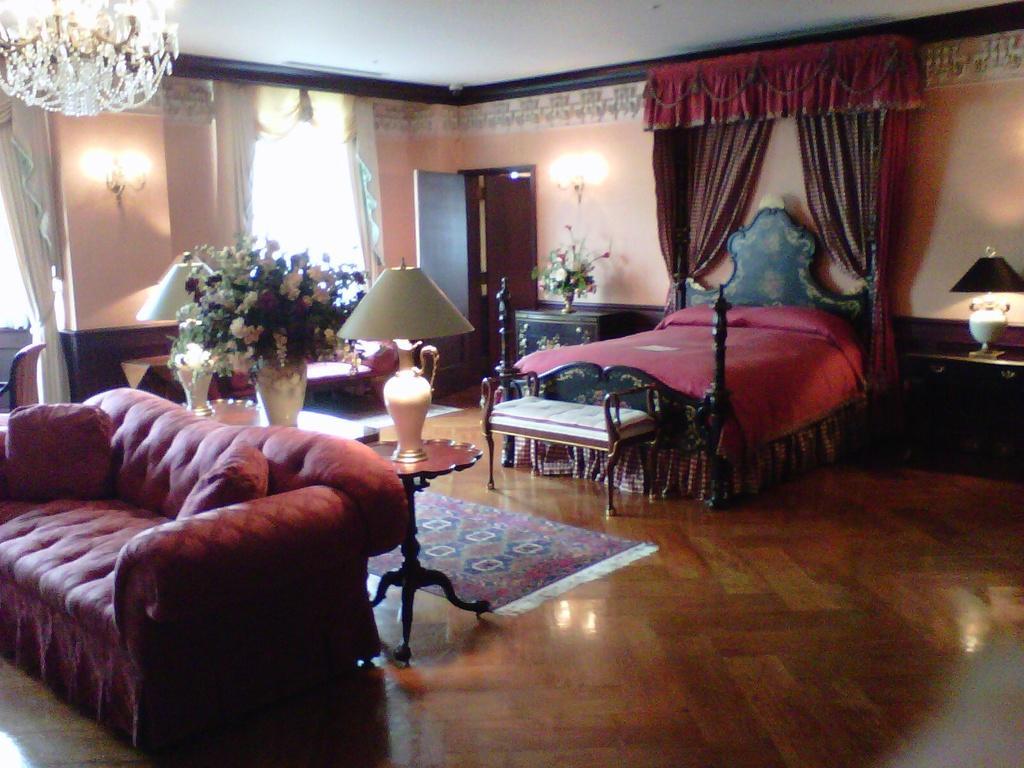Could you give a brief overview of what you see in this image? In the image we can see there is a sofa and a bed at the back and a table lamp in between and a door mat on the floor. 